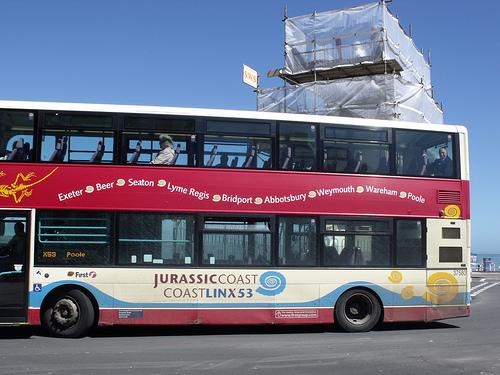Question: where are the blue graphics?
Choices:
A. On the ceiling of the bus.
B. On the bus seats.
C. On the side of the bus.
D. The lower part of the bus.
Answer with the letter. Answer: D Question: what color is the sky?
Choices:
A. Blue.
B. White.
C. Purple.
D. Grey.
Answer with the letter. Answer: A Question: how many floors does the bus have?
Choices:
A. 1.
B. 3.
C. 2.
D. 4.
Answer with the letter. Answer: C 